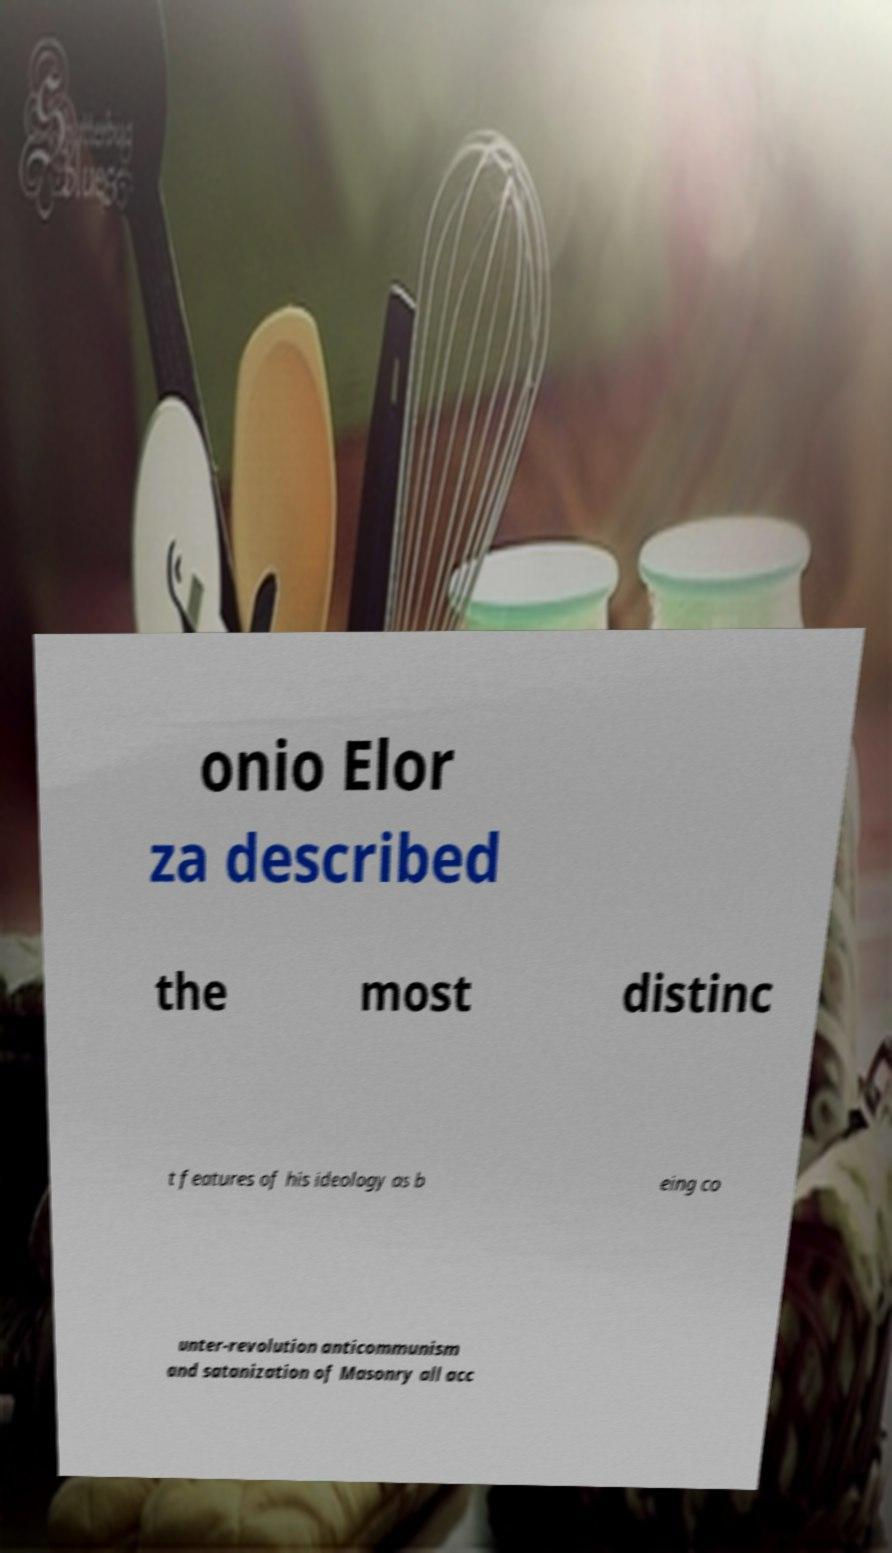Could you extract and type out the text from this image? onio Elor za described the most distinc t features of his ideology as b eing co unter-revolution anticommunism and satanization of Masonry all acc 